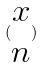Convert formula to latex. <formula><loc_0><loc_0><loc_500><loc_500>( \begin{matrix} x \\ n \end{matrix} )</formula> 